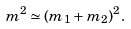<formula> <loc_0><loc_0><loc_500><loc_500>m ^ { 2 } \simeq ( m _ { 1 } + m _ { 2 } ) ^ { 2 } .</formula> 